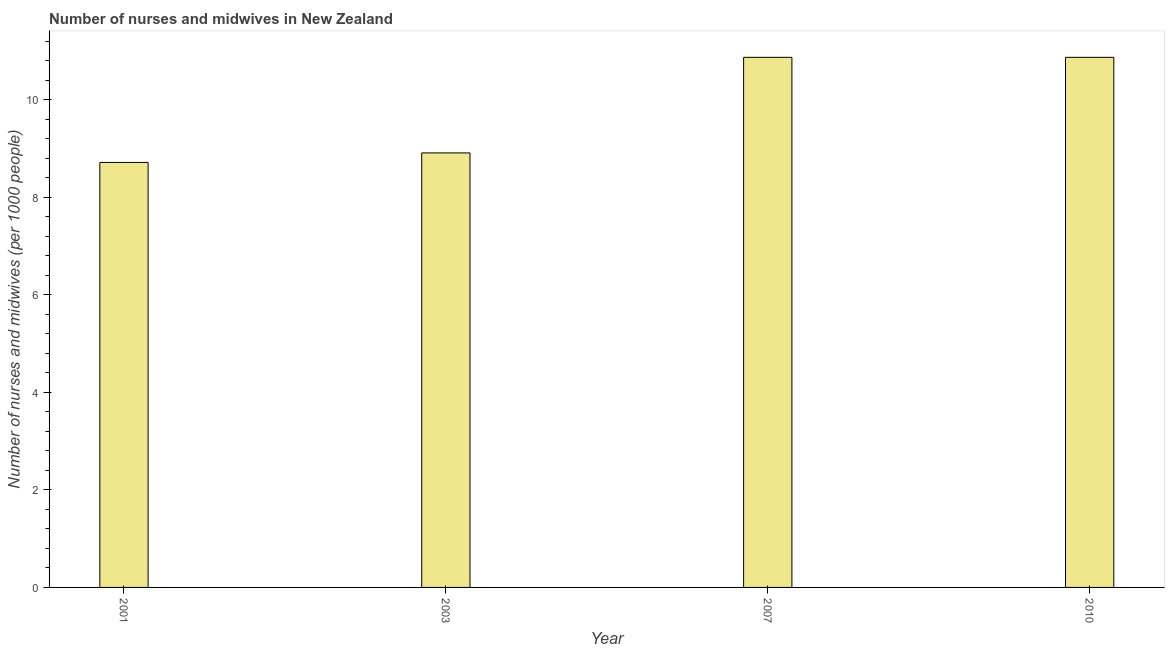Does the graph contain any zero values?
Provide a succinct answer. No. What is the title of the graph?
Provide a short and direct response. Number of nurses and midwives in New Zealand. What is the label or title of the X-axis?
Make the answer very short. Year. What is the label or title of the Y-axis?
Your answer should be compact. Number of nurses and midwives (per 1000 people). What is the number of nurses and midwives in 2007?
Offer a terse response. 10.87. Across all years, what is the maximum number of nurses and midwives?
Your answer should be very brief. 10.87. Across all years, what is the minimum number of nurses and midwives?
Provide a succinct answer. 8.71. What is the sum of the number of nurses and midwives?
Make the answer very short. 39.36. What is the difference between the number of nurses and midwives in 2001 and 2010?
Ensure brevity in your answer.  -2.15. What is the average number of nurses and midwives per year?
Offer a very short reply. 9.84. What is the median number of nurses and midwives?
Offer a terse response. 9.89. Do a majority of the years between 2001 and 2010 (inclusive) have number of nurses and midwives greater than 0.4 ?
Your answer should be very brief. Yes. What is the ratio of the number of nurses and midwives in 2001 to that in 2010?
Your answer should be compact. 0.8. Is the number of nurses and midwives in 2003 less than that in 2007?
Offer a very short reply. Yes. Is the difference between the number of nurses and midwives in 2001 and 2007 greater than the difference between any two years?
Your answer should be compact. Yes. What is the difference between the highest and the second highest number of nurses and midwives?
Ensure brevity in your answer.  0. What is the difference between the highest and the lowest number of nurses and midwives?
Keep it short and to the point. 2.15. In how many years, is the number of nurses and midwives greater than the average number of nurses and midwives taken over all years?
Provide a succinct answer. 2. How many years are there in the graph?
Offer a terse response. 4. What is the difference between two consecutive major ticks on the Y-axis?
Your response must be concise. 2. What is the Number of nurses and midwives (per 1000 people) in 2001?
Your answer should be very brief. 8.71. What is the Number of nurses and midwives (per 1000 people) of 2003?
Keep it short and to the point. 8.91. What is the Number of nurses and midwives (per 1000 people) of 2007?
Keep it short and to the point. 10.87. What is the Number of nurses and midwives (per 1000 people) in 2010?
Ensure brevity in your answer.  10.87. What is the difference between the Number of nurses and midwives (per 1000 people) in 2001 and 2003?
Keep it short and to the point. -0.2. What is the difference between the Number of nurses and midwives (per 1000 people) in 2001 and 2007?
Your answer should be compact. -2.15. What is the difference between the Number of nurses and midwives (per 1000 people) in 2001 and 2010?
Offer a very short reply. -2.15. What is the difference between the Number of nurses and midwives (per 1000 people) in 2003 and 2007?
Your response must be concise. -1.96. What is the difference between the Number of nurses and midwives (per 1000 people) in 2003 and 2010?
Give a very brief answer. -1.96. What is the difference between the Number of nurses and midwives (per 1000 people) in 2007 and 2010?
Your answer should be compact. 0. What is the ratio of the Number of nurses and midwives (per 1000 people) in 2001 to that in 2003?
Your answer should be compact. 0.98. What is the ratio of the Number of nurses and midwives (per 1000 people) in 2001 to that in 2007?
Offer a terse response. 0.8. What is the ratio of the Number of nurses and midwives (per 1000 people) in 2001 to that in 2010?
Offer a very short reply. 0.8. What is the ratio of the Number of nurses and midwives (per 1000 people) in 2003 to that in 2007?
Provide a short and direct response. 0.82. What is the ratio of the Number of nurses and midwives (per 1000 people) in 2003 to that in 2010?
Make the answer very short. 0.82. What is the ratio of the Number of nurses and midwives (per 1000 people) in 2007 to that in 2010?
Ensure brevity in your answer.  1. 